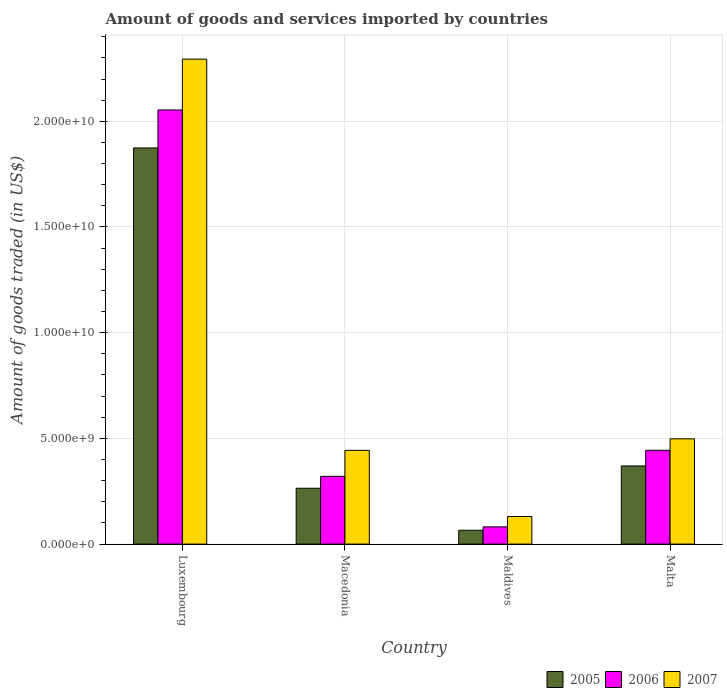Are the number of bars per tick equal to the number of legend labels?
Offer a terse response. Yes. Are the number of bars on each tick of the X-axis equal?
Make the answer very short. Yes. How many bars are there on the 3rd tick from the right?
Give a very brief answer. 3. What is the label of the 1st group of bars from the left?
Ensure brevity in your answer.  Luxembourg. In how many cases, is the number of bars for a given country not equal to the number of legend labels?
Make the answer very short. 0. What is the total amount of goods and services imported in 2007 in Luxembourg?
Your answer should be compact. 2.29e+1. Across all countries, what is the maximum total amount of goods and services imported in 2006?
Keep it short and to the point. 2.05e+1. Across all countries, what is the minimum total amount of goods and services imported in 2005?
Ensure brevity in your answer.  6.55e+08. In which country was the total amount of goods and services imported in 2006 maximum?
Your answer should be compact. Luxembourg. In which country was the total amount of goods and services imported in 2006 minimum?
Keep it short and to the point. Maldives. What is the total total amount of goods and services imported in 2006 in the graph?
Offer a very short reply. 2.90e+1. What is the difference between the total amount of goods and services imported in 2006 in Luxembourg and that in Macedonia?
Your answer should be very brief. 1.73e+1. What is the difference between the total amount of goods and services imported in 2005 in Luxembourg and the total amount of goods and services imported in 2007 in Maldives?
Make the answer very short. 1.74e+1. What is the average total amount of goods and services imported in 2007 per country?
Offer a very short reply. 8.41e+09. What is the difference between the total amount of goods and services imported of/in 2007 and total amount of goods and services imported of/in 2006 in Malta?
Offer a very short reply. 5.41e+08. What is the ratio of the total amount of goods and services imported in 2006 in Luxembourg to that in Macedonia?
Your response must be concise. 6.41. Is the total amount of goods and services imported in 2007 in Luxembourg less than that in Maldives?
Offer a very short reply. No. What is the difference between the highest and the second highest total amount of goods and services imported in 2007?
Offer a very short reply. -5.45e+08. What is the difference between the highest and the lowest total amount of goods and services imported in 2007?
Your answer should be very brief. 2.16e+1. Is the sum of the total amount of goods and services imported in 2006 in Luxembourg and Macedonia greater than the maximum total amount of goods and services imported in 2005 across all countries?
Give a very brief answer. Yes. What does the 2nd bar from the right in Malta represents?
Give a very brief answer. 2006. Is it the case that in every country, the sum of the total amount of goods and services imported in 2005 and total amount of goods and services imported in 2006 is greater than the total amount of goods and services imported in 2007?
Give a very brief answer. Yes. How many legend labels are there?
Your response must be concise. 3. How are the legend labels stacked?
Ensure brevity in your answer.  Horizontal. What is the title of the graph?
Give a very brief answer. Amount of goods and services imported by countries. What is the label or title of the X-axis?
Ensure brevity in your answer.  Country. What is the label or title of the Y-axis?
Give a very brief answer. Amount of goods traded (in US$). What is the Amount of goods traded (in US$) of 2005 in Luxembourg?
Offer a very short reply. 1.87e+1. What is the Amount of goods traded (in US$) in 2006 in Luxembourg?
Provide a succinct answer. 2.05e+1. What is the Amount of goods traded (in US$) of 2007 in Luxembourg?
Your response must be concise. 2.29e+1. What is the Amount of goods traded (in US$) of 2005 in Macedonia?
Ensure brevity in your answer.  2.64e+09. What is the Amount of goods traded (in US$) in 2006 in Macedonia?
Offer a very short reply. 3.21e+09. What is the Amount of goods traded (in US$) of 2007 in Macedonia?
Your answer should be compact. 4.43e+09. What is the Amount of goods traded (in US$) in 2005 in Maldives?
Give a very brief answer. 6.55e+08. What is the Amount of goods traded (in US$) of 2006 in Maldives?
Provide a short and direct response. 8.15e+08. What is the Amount of goods traded (in US$) of 2007 in Maldives?
Make the answer very short. 1.30e+09. What is the Amount of goods traded (in US$) of 2005 in Malta?
Give a very brief answer. 3.70e+09. What is the Amount of goods traded (in US$) in 2006 in Malta?
Your response must be concise. 4.44e+09. What is the Amount of goods traded (in US$) of 2007 in Malta?
Your response must be concise. 4.98e+09. Across all countries, what is the maximum Amount of goods traded (in US$) in 2005?
Your answer should be compact. 1.87e+1. Across all countries, what is the maximum Amount of goods traded (in US$) in 2006?
Keep it short and to the point. 2.05e+1. Across all countries, what is the maximum Amount of goods traded (in US$) of 2007?
Provide a short and direct response. 2.29e+1. Across all countries, what is the minimum Amount of goods traded (in US$) in 2005?
Make the answer very short. 6.55e+08. Across all countries, what is the minimum Amount of goods traded (in US$) of 2006?
Your response must be concise. 8.15e+08. Across all countries, what is the minimum Amount of goods traded (in US$) in 2007?
Offer a terse response. 1.30e+09. What is the total Amount of goods traded (in US$) in 2005 in the graph?
Give a very brief answer. 2.57e+1. What is the total Amount of goods traded (in US$) in 2006 in the graph?
Provide a short and direct response. 2.90e+1. What is the total Amount of goods traded (in US$) in 2007 in the graph?
Your response must be concise. 3.37e+1. What is the difference between the Amount of goods traded (in US$) in 2005 in Luxembourg and that in Macedonia?
Keep it short and to the point. 1.61e+1. What is the difference between the Amount of goods traded (in US$) of 2006 in Luxembourg and that in Macedonia?
Make the answer very short. 1.73e+1. What is the difference between the Amount of goods traded (in US$) of 2007 in Luxembourg and that in Macedonia?
Your answer should be compact. 1.85e+1. What is the difference between the Amount of goods traded (in US$) of 2005 in Luxembourg and that in Maldives?
Your answer should be very brief. 1.81e+1. What is the difference between the Amount of goods traded (in US$) in 2006 in Luxembourg and that in Maldives?
Your answer should be compact. 1.97e+1. What is the difference between the Amount of goods traded (in US$) in 2007 in Luxembourg and that in Maldives?
Give a very brief answer. 2.16e+1. What is the difference between the Amount of goods traded (in US$) of 2005 in Luxembourg and that in Malta?
Your answer should be compact. 1.50e+1. What is the difference between the Amount of goods traded (in US$) of 2006 in Luxembourg and that in Malta?
Make the answer very short. 1.61e+1. What is the difference between the Amount of goods traded (in US$) in 2007 in Luxembourg and that in Malta?
Ensure brevity in your answer.  1.80e+1. What is the difference between the Amount of goods traded (in US$) in 2005 in Macedonia and that in Maldives?
Provide a succinct answer. 1.99e+09. What is the difference between the Amount of goods traded (in US$) of 2006 in Macedonia and that in Maldives?
Offer a terse response. 2.39e+09. What is the difference between the Amount of goods traded (in US$) in 2007 in Macedonia and that in Maldives?
Give a very brief answer. 3.13e+09. What is the difference between the Amount of goods traded (in US$) in 2005 in Macedonia and that in Malta?
Ensure brevity in your answer.  -1.05e+09. What is the difference between the Amount of goods traded (in US$) in 2006 in Macedonia and that in Malta?
Provide a short and direct response. -1.23e+09. What is the difference between the Amount of goods traded (in US$) in 2007 in Macedonia and that in Malta?
Keep it short and to the point. -5.45e+08. What is the difference between the Amount of goods traded (in US$) in 2005 in Maldives and that in Malta?
Make the answer very short. -3.04e+09. What is the difference between the Amount of goods traded (in US$) in 2006 in Maldives and that in Malta?
Offer a terse response. -3.62e+09. What is the difference between the Amount of goods traded (in US$) of 2007 in Maldives and that in Malta?
Provide a short and direct response. -3.67e+09. What is the difference between the Amount of goods traded (in US$) of 2005 in Luxembourg and the Amount of goods traded (in US$) of 2006 in Macedonia?
Offer a very short reply. 1.55e+1. What is the difference between the Amount of goods traded (in US$) in 2005 in Luxembourg and the Amount of goods traded (in US$) in 2007 in Macedonia?
Give a very brief answer. 1.43e+1. What is the difference between the Amount of goods traded (in US$) of 2006 in Luxembourg and the Amount of goods traded (in US$) of 2007 in Macedonia?
Offer a very short reply. 1.61e+1. What is the difference between the Amount of goods traded (in US$) of 2005 in Luxembourg and the Amount of goods traded (in US$) of 2006 in Maldives?
Your answer should be compact. 1.79e+1. What is the difference between the Amount of goods traded (in US$) in 2005 in Luxembourg and the Amount of goods traded (in US$) in 2007 in Maldives?
Provide a succinct answer. 1.74e+1. What is the difference between the Amount of goods traded (in US$) of 2006 in Luxembourg and the Amount of goods traded (in US$) of 2007 in Maldives?
Make the answer very short. 1.92e+1. What is the difference between the Amount of goods traded (in US$) in 2005 in Luxembourg and the Amount of goods traded (in US$) in 2006 in Malta?
Your response must be concise. 1.43e+1. What is the difference between the Amount of goods traded (in US$) in 2005 in Luxembourg and the Amount of goods traded (in US$) in 2007 in Malta?
Provide a short and direct response. 1.38e+1. What is the difference between the Amount of goods traded (in US$) of 2006 in Luxembourg and the Amount of goods traded (in US$) of 2007 in Malta?
Offer a terse response. 1.56e+1. What is the difference between the Amount of goods traded (in US$) of 2005 in Macedonia and the Amount of goods traded (in US$) of 2006 in Maldives?
Your answer should be compact. 1.83e+09. What is the difference between the Amount of goods traded (in US$) in 2005 in Macedonia and the Amount of goods traded (in US$) in 2007 in Maldives?
Make the answer very short. 1.34e+09. What is the difference between the Amount of goods traded (in US$) of 2006 in Macedonia and the Amount of goods traded (in US$) of 2007 in Maldives?
Your answer should be compact. 1.90e+09. What is the difference between the Amount of goods traded (in US$) in 2005 in Macedonia and the Amount of goods traded (in US$) in 2006 in Malta?
Provide a succinct answer. -1.80e+09. What is the difference between the Amount of goods traded (in US$) of 2005 in Macedonia and the Amount of goods traded (in US$) of 2007 in Malta?
Ensure brevity in your answer.  -2.34e+09. What is the difference between the Amount of goods traded (in US$) in 2006 in Macedonia and the Amount of goods traded (in US$) in 2007 in Malta?
Give a very brief answer. -1.77e+09. What is the difference between the Amount of goods traded (in US$) of 2005 in Maldives and the Amount of goods traded (in US$) of 2006 in Malta?
Provide a succinct answer. -3.78e+09. What is the difference between the Amount of goods traded (in US$) in 2005 in Maldives and the Amount of goods traded (in US$) in 2007 in Malta?
Make the answer very short. -4.32e+09. What is the difference between the Amount of goods traded (in US$) in 2006 in Maldives and the Amount of goods traded (in US$) in 2007 in Malta?
Offer a very short reply. -4.16e+09. What is the average Amount of goods traded (in US$) of 2005 per country?
Ensure brevity in your answer.  6.43e+09. What is the average Amount of goods traded (in US$) in 2006 per country?
Provide a short and direct response. 7.25e+09. What is the average Amount of goods traded (in US$) in 2007 per country?
Give a very brief answer. 8.41e+09. What is the difference between the Amount of goods traded (in US$) of 2005 and Amount of goods traded (in US$) of 2006 in Luxembourg?
Your response must be concise. -1.80e+09. What is the difference between the Amount of goods traded (in US$) of 2005 and Amount of goods traded (in US$) of 2007 in Luxembourg?
Your answer should be very brief. -4.20e+09. What is the difference between the Amount of goods traded (in US$) of 2006 and Amount of goods traded (in US$) of 2007 in Luxembourg?
Make the answer very short. -2.40e+09. What is the difference between the Amount of goods traded (in US$) in 2005 and Amount of goods traded (in US$) in 2006 in Macedonia?
Provide a succinct answer. -5.64e+08. What is the difference between the Amount of goods traded (in US$) in 2005 and Amount of goods traded (in US$) in 2007 in Macedonia?
Provide a succinct answer. -1.79e+09. What is the difference between the Amount of goods traded (in US$) of 2006 and Amount of goods traded (in US$) of 2007 in Macedonia?
Offer a terse response. -1.23e+09. What is the difference between the Amount of goods traded (in US$) in 2005 and Amount of goods traded (in US$) in 2006 in Maldives?
Give a very brief answer. -1.60e+08. What is the difference between the Amount of goods traded (in US$) in 2005 and Amount of goods traded (in US$) in 2007 in Maldives?
Offer a terse response. -6.49e+08. What is the difference between the Amount of goods traded (in US$) of 2006 and Amount of goods traded (in US$) of 2007 in Maldives?
Your answer should be compact. -4.89e+08. What is the difference between the Amount of goods traded (in US$) of 2005 and Amount of goods traded (in US$) of 2006 in Malta?
Ensure brevity in your answer.  -7.41e+08. What is the difference between the Amount of goods traded (in US$) in 2005 and Amount of goods traded (in US$) in 2007 in Malta?
Ensure brevity in your answer.  -1.28e+09. What is the difference between the Amount of goods traded (in US$) in 2006 and Amount of goods traded (in US$) in 2007 in Malta?
Offer a terse response. -5.41e+08. What is the ratio of the Amount of goods traded (in US$) of 2005 in Luxembourg to that in Macedonia?
Offer a terse response. 7.09. What is the ratio of the Amount of goods traded (in US$) of 2006 in Luxembourg to that in Macedonia?
Provide a succinct answer. 6.41. What is the ratio of the Amount of goods traded (in US$) in 2007 in Luxembourg to that in Macedonia?
Your answer should be very brief. 5.17. What is the ratio of the Amount of goods traded (in US$) of 2005 in Luxembourg to that in Maldives?
Your response must be concise. 28.59. What is the ratio of the Amount of goods traded (in US$) of 2006 in Luxembourg to that in Maldives?
Offer a terse response. 25.19. What is the ratio of the Amount of goods traded (in US$) in 2007 in Luxembourg to that in Maldives?
Keep it short and to the point. 17.58. What is the ratio of the Amount of goods traded (in US$) of 2005 in Luxembourg to that in Malta?
Provide a short and direct response. 5.07. What is the ratio of the Amount of goods traded (in US$) in 2006 in Luxembourg to that in Malta?
Provide a short and direct response. 4.63. What is the ratio of the Amount of goods traded (in US$) of 2007 in Luxembourg to that in Malta?
Your response must be concise. 4.61. What is the ratio of the Amount of goods traded (in US$) of 2005 in Macedonia to that in Maldives?
Offer a very short reply. 4.03. What is the ratio of the Amount of goods traded (in US$) in 2006 in Macedonia to that in Maldives?
Provide a short and direct response. 3.93. What is the ratio of the Amount of goods traded (in US$) of 2007 in Macedonia to that in Maldives?
Give a very brief answer. 3.4. What is the ratio of the Amount of goods traded (in US$) of 2005 in Macedonia to that in Malta?
Your answer should be very brief. 0.71. What is the ratio of the Amount of goods traded (in US$) of 2006 in Macedonia to that in Malta?
Offer a very short reply. 0.72. What is the ratio of the Amount of goods traded (in US$) in 2007 in Macedonia to that in Malta?
Offer a terse response. 0.89. What is the ratio of the Amount of goods traded (in US$) of 2005 in Maldives to that in Malta?
Make the answer very short. 0.18. What is the ratio of the Amount of goods traded (in US$) in 2006 in Maldives to that in Malta?
Provide a short and direct response. 0.18. What is the ratio of the Amount of goods traded (in US$) of 2007 in Maldives to that in Malta?
Ensure brevity in your answer.  0.26. What is the difference between the highest and the second highest Amount of goods traded (in US$) of 2005?
Your response must be concise. 1.50e+1. What is the difference between the highest and the second highest Amount of goods traded (in US$) in 2006?
Your response must be concise. 1.61e+1. What is the difference between the highest and the second highest Amount of goods traded (in US$) of 2007?
Keep it short and to the point. 1.80e+1. What is the difference between the highest and the lowest Amount of goods traded (in US$) of 2005?
Ensure brevity in your answer.  1.81e+1. What is the difference between the highest and the lowest Amount of goods traded (in US$) of 2006?
Provide a short and direct response. 1.97e+1. What is the difference between the highest and the lowest Amount of goods traded (in US$) of 2007?
Make the answer very short. 2.16e+1. 